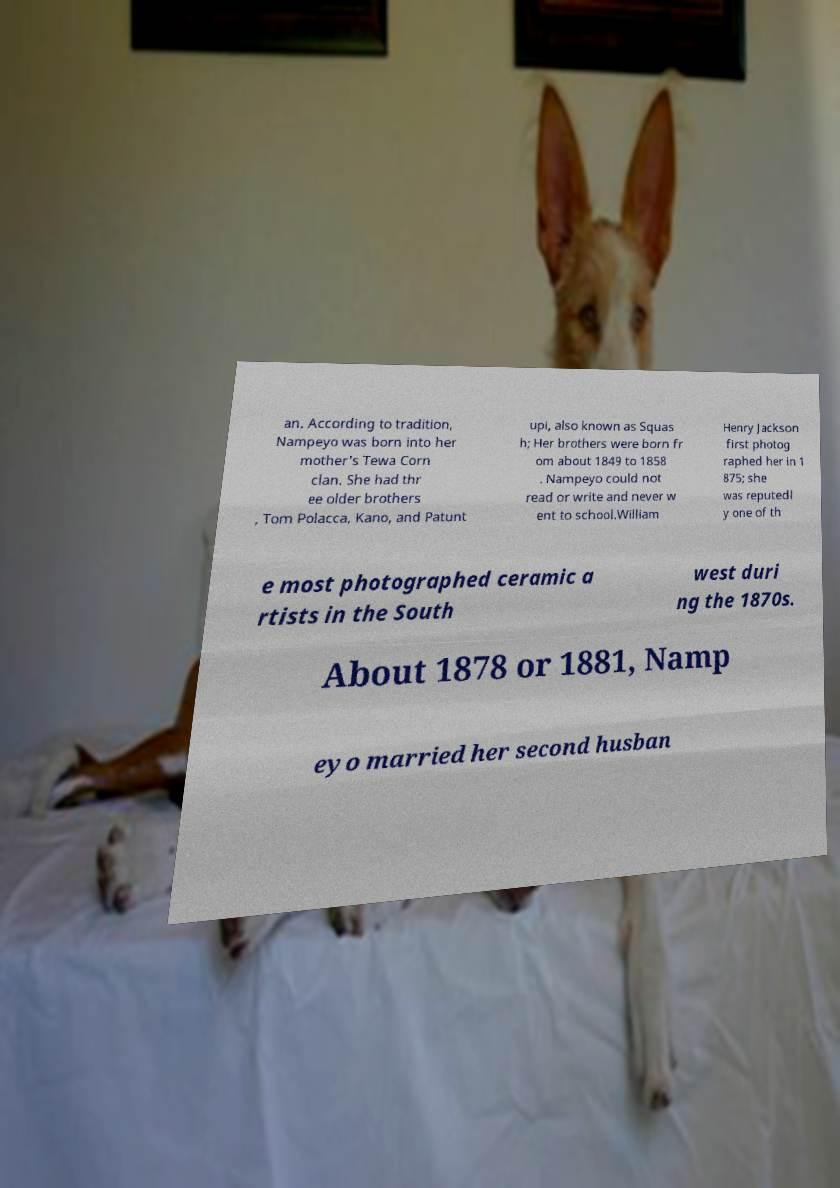Please read and relay the text visible in this image. What does it say? an. According to tradition, Nampeyo was born into her mother's Tewa Corn clan. She had thr ee older brothers , Tom Polacca, Kano, and Patunt upi, also known as Squas h; Her brothers were born fr om about 1849 to 1858 . Nampeyo could not read or write and never w ent to school.William Henry Jackson first photog raphed her in 1 875; she was reputedl y one of th e most photographed ceramic a rtists in the South west duri ng the 1870s. About 1878 or 1881, Namp eyo married her second husban 